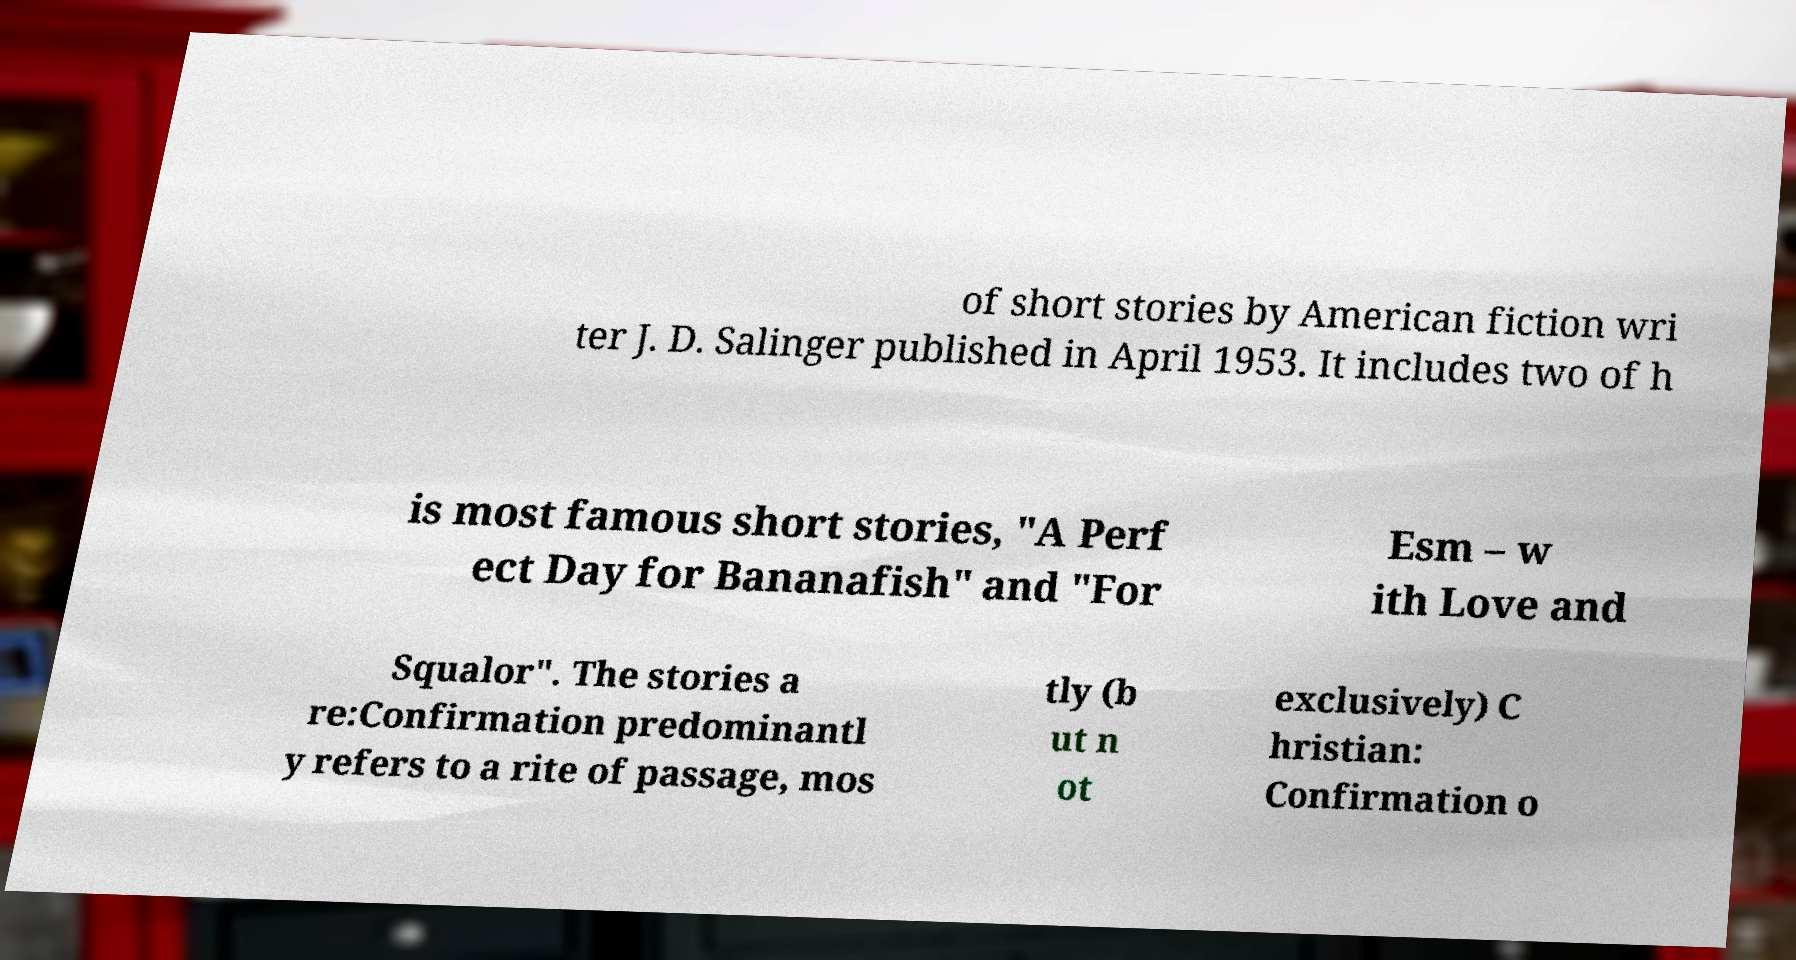Please identify and transcribe the text found in this image. of short stories by American fiction wri ter J. D. Salinger published in April 1953. It includes two of h is most famous short stories, "A Perf ect Day for Bananafish" and "For Esm – w ith Love and Squalor". The stories a re:Confirmation predominantl y refers to a rite of passage, mos tly (b ut n ot exclusively) C hristian: Confirmation o 